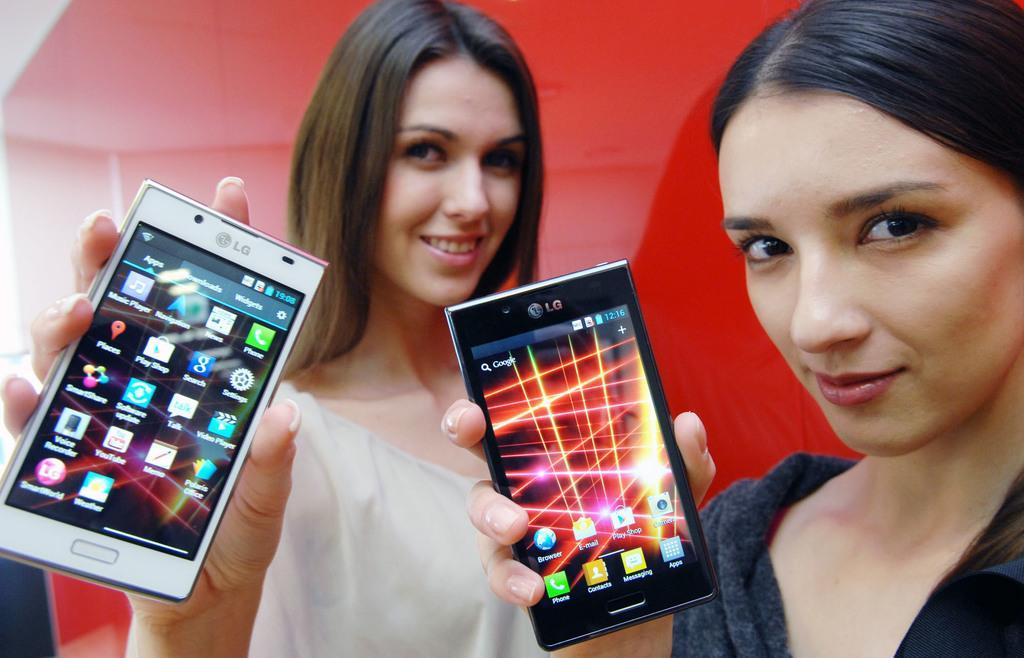Describe this image in one or two sentences. This is the picture of two persons, the two persons are holding a mobile and the screen is on, In the mobile we can see the different applications. Background of this people is in red color. 